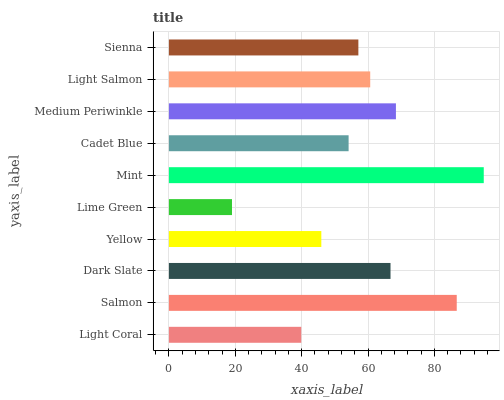Is Lime Green the minimum?
Answer yes or no. Yes. Is Mint the maximum?
Answer yes or no. Yes. Is Salmon the minimum?
Answer yes or no. No. Is Salmon the maximum?
Answer yes or no. No. Is Salmon greater than Light Coral?
Answer yes or no. Yes. Is Light Coral less than Salmon?
Answer yes or no. Yes. Is Light Coral greater than Salmon?
Answer yes or no. No. Is Salmon less than Light Coral?
Answer yes or no. No. Is Light Salmon the high median?
Answer yes or no. Yes. Is Sienna the low median?
Answer yes or no. Yes. Is Lime Green the high median?
Answer yes or no. No. Is Yellow the low median?
Answer yes or no. No. 